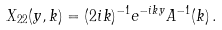<formula> <loc_0><loc_0><loc_500><loc_500>X _ { 2 2 } ( y , k ) = ( 2 i k ) ^ { - 1 } e ^ { - i k y } A ^ { - 1 } ( k ) \, .</formula> 